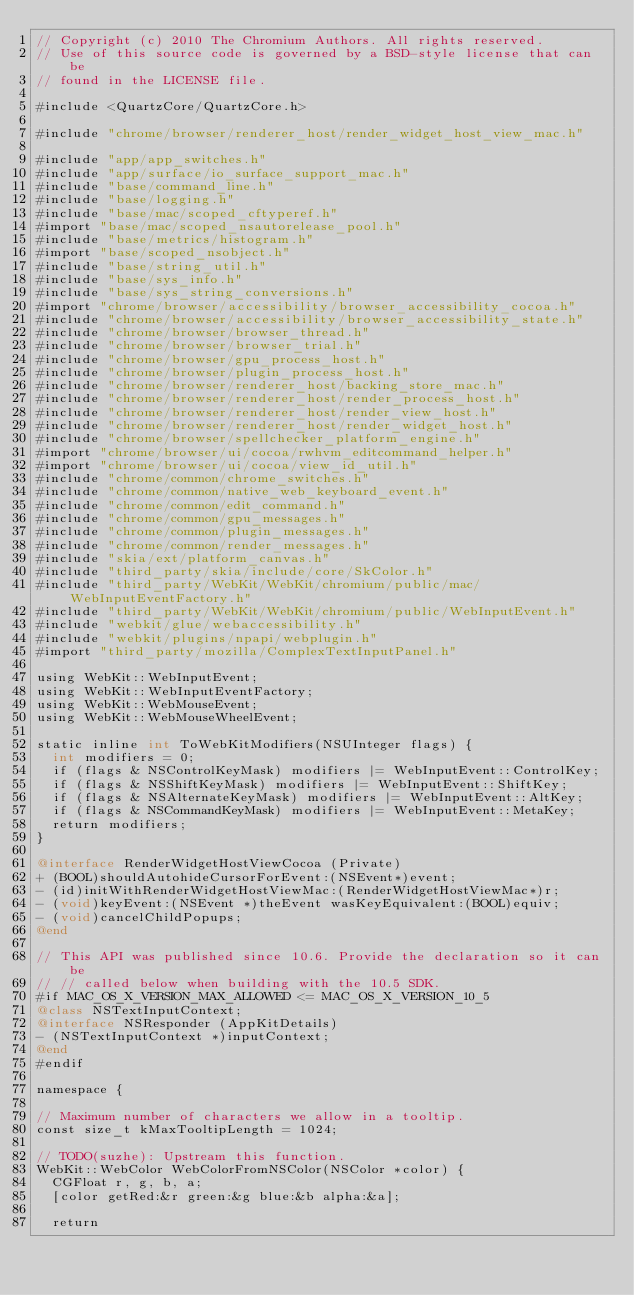<code> <loc_0><loc_0><loc_500><loc_500><_ObjectiveC_>// Copyright (c) 2010 The Chromium Authors. All rights reserved.
// Use of this source code is governed by a BSD-style license that can be
// found in the LICENSE file.

#include <QuartzCore/QuartzCore.h>

#include "chrome/browser/renderer_host/render_widget_host_view_mac.h"

#include "app/app_switches.h"
#include "app/surface/io_surface_support_mac.h"
#include "base/command_line.h"
#include "base/logging.h"
#include "base/mac/scoped_cftyperef.h"
#import "base/mac/scoped_nsautorelease_pool.h"
#include "base/metrics/histogram.h"
#import "base/scoped_nsobject.h"
#include "base/string_util.h"
#include "base/sys_info.h"
#include "base/sys_string_conversions.h"
#import "chrome/browser/accessibility/browser_accessibility_cocoa.h"
#include "chrome/browser/accessibility/browser_accessibility_state.h"
#include "chrome/browser/browser_thread.h"
#include "chrome/browser/browser_trial.h"
#include "chrome/browser/gpu_process_host.h"
#include "chrome/browser/plugin_process_host.h"
#include "chrome/browser/renderer_host/backing_store_mac.h"
#include "chrome/browser/renderer_host/render_process_host.h"
#include "chrome/browser/renderer_host/render_view_host.h"
#include "chrome/browser/renderer_host/render_widget_host.h"
#include "chrome/browser/spellchecker_platform_engine.h"
#import "chrome/browser/ui/cocoa/rwhvm_editcommand_helper.h"
#import "chrome/browser/ui/cocoa/view_id_util.h"
#include "chrome/common/chrome_switches.h"
#include "chrome/common/native_web_keyboard_event.h"
#include "chrome/common/edit_command.h"
#include "chrome/common/gpu_messages.h"
#include "chrome/common/plugin_messages.h"
#include "chrome/common/render_messages.h"
#include "skia/ext/platform_canvas.h"
#include "third_party/skia/include/core/SkColor.h"
#include "third_party/WebKit/WebKit/chromium/public/mac/WebInputEventFactory.h"
#include "third_party/WebKit/WebKit/chromium/public/WebInputEvent.h"
#include "webkit/glue/webaccessibility.h"
#include "webkit/plugins/npapi/webplugin.h"
#import "third_party/mozilla/ComplexTextInputPanel.h"

using WebKit::WebInputEvent;
using WebKit::WebInputEventFactory;
using WebKit::WebMouseEvent;
using WebKit::WebMouseWheelEvent;

static inline int ToWebKitModifiers(NSUInteger flags) {
  int modifiers = 0;
  if (flags & NSControlKeyMask) modifiers |= WebInputEvent::ControlKey;
  if (flags & NSShiftKeyMask) modifiers |= WebInputEvent::ShiftKey;
  if (flags & NSAlternateKeyMask) modifiers |= WebInputEvent::AltKey;
  if (flags & NSCommandKeyMask) modifiers |= WebInputEvent::MetaKey;
  return modifiers;
}

@interface RenderWidgetHostViewCocoa (Private)
+ (BOOL)shouldAutohideCursorForEvent:(NSEvent*)event;
- (id)initWithRenderWidgetHostViewMac:(RenderWidgetHostViewMac*)r;
- (void)keyEvent:(NSEvent *)theEvent wasKeyEquivalent:(BOOL)equiv;
- (void)cancelChildPopups;
@end

// This API was published since 10.6. Provide the declaration so it can be
// // called below when building with the 10.5 SDK.
#if MAC_OS_X_VERSION_MAX_ALLOWED <= MAC_OS_X_VERSION_10_5
@class NSTextInputContext;
@interface NSResponder (AppKitDetails)
- (NSTextInputContext *)inputContext;
@end
#endif

namespace {

// Maximum number of characters we allow in a tooltip.
const size_t kMaxTooltipLength = 1024;

// TODO(suzhe): Upstream this function.
WebKit::WebColor WebColorFromNSColor(NSColor *color) {
  CGFloat r, g, b, a;
  [color getRed:&r green:&g blue:&b alpha:&a];

  return</code> 